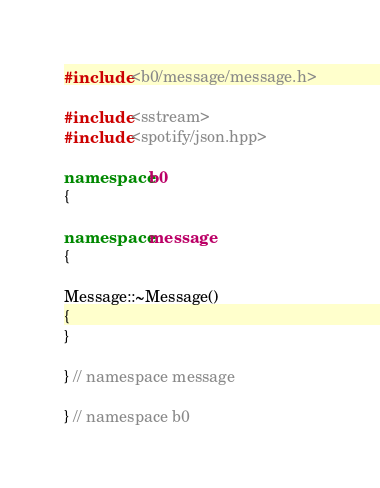Convert code to text. <code><loc_0><loc_0><loc_500><loc_500><_C++_>#include <b0/message/message.h>

#include <sstream>
#include <spotify/json.hpp>

namespace b0
{

namespace message
{

Message::~Message()
{
}

} // namespace message

} // namespace b0

</code> 